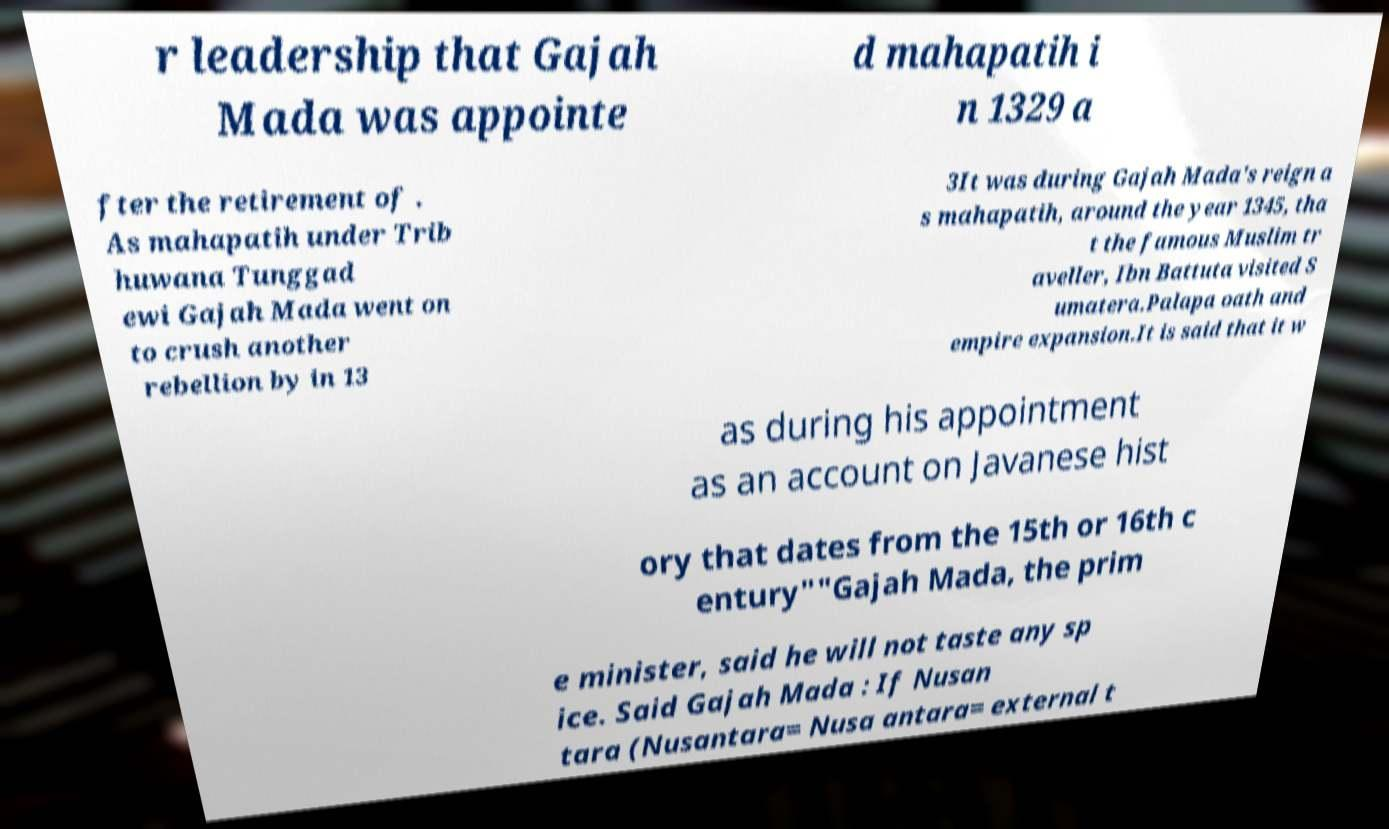For documentation purposes, I need the text within this image transcribed. Could you provide that? r leadership that Gajah Mada was appointe d mahapatih i n 1329 a fter the retirement of . As mahapatih under Trib huwana Tunggad ewi Gajah Mada went on to crush another rebellion by in 13 3It was during Gajah Mada's reign a s mahapatih, around the year 1345, tha t the famous Muslim tr aveller, Ibn Battuta visited S umatera.Palapa oath and empire expansion.It is said that it w as during his appointment as an account on Javanese hist ory that dates from the 15th or 16th c entury""Gajah Mada, the prim e minister, said he will not taste any sp ice. Said Gajah Mada : If Nusan tara (Nusantara= Nusa antara= external t 